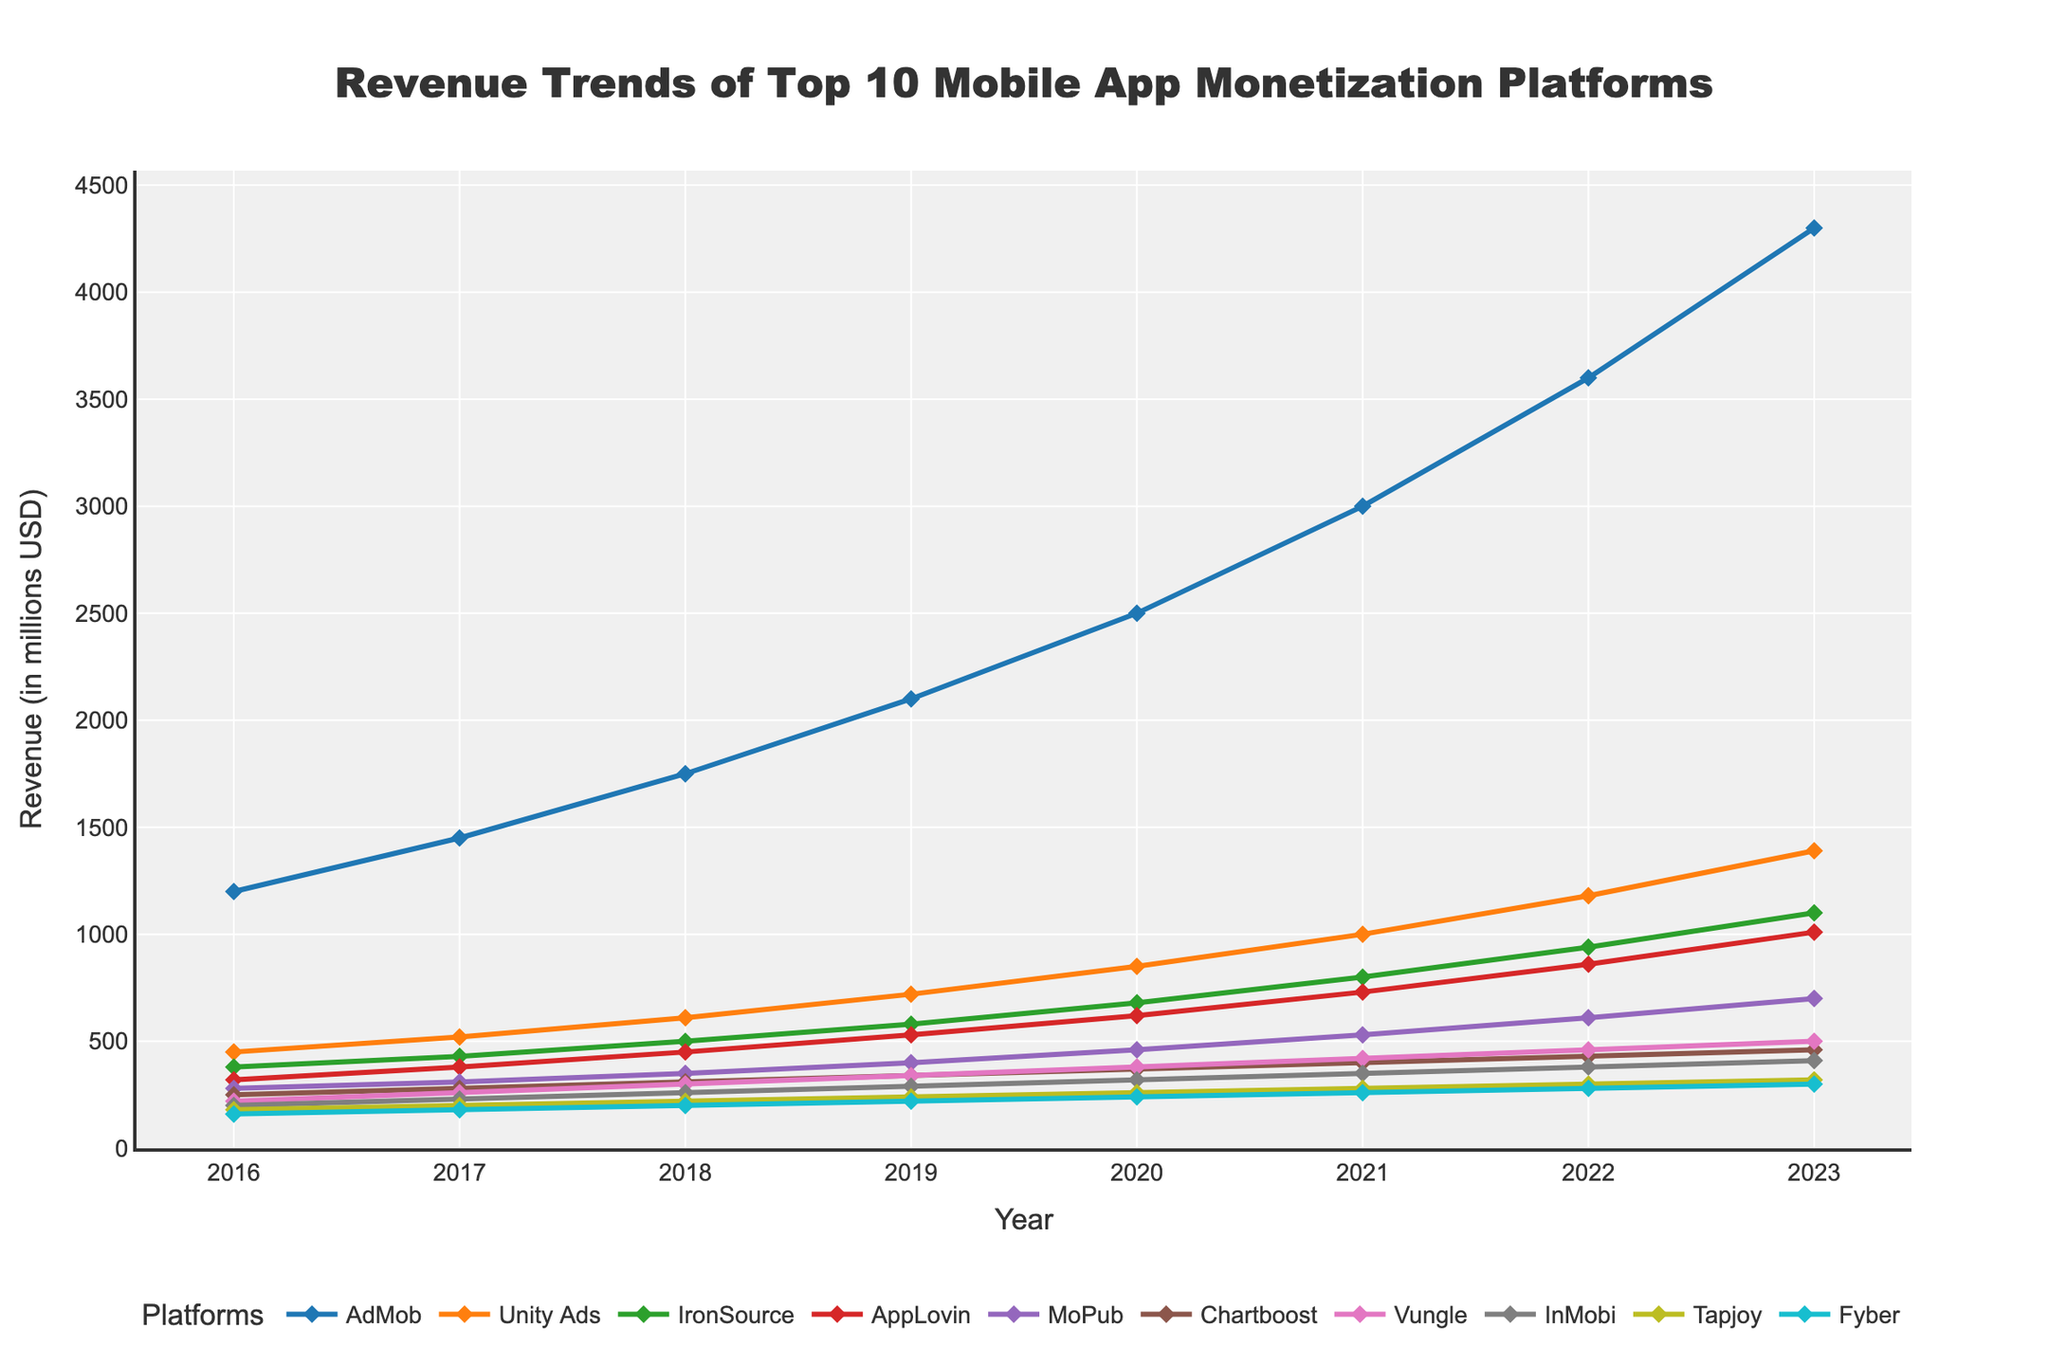What is the overall revenue trend of AdMob from 2016 to 2023? By examining the plot for the AdMob line (blue line), we can see that the revenue consistently rises each year from 1200 million USD in 2016 to 4300 million USD in 2023.
Answer: Increasing Which platform had the highest revenue in 2020? By checking the heights of the lines for the year 2020, it's clear that AdMob had the highest revenue at 2500 million USD.
Answer: AdMob How much did Unity Ads' revenue increase between 2018 and 2022? Looking at the line for Unity Ads (orange line), the revenue in 2018 was 610 million USD and in 2022 it was 1180 million USD. The increase is 1180 - 610 = 570 million USD.
Answer: 570 million USD Between Tapjoy and Fyber, which platform has shown a more consistent growth rate? Both Tapjoy (green line) and Fyber (grey line) show growth, but Tapjoy's annual increments (20-30 million USD) appear more consistent over the years compared to Fyber's smaller and steadier increments (15-20 million USD).
Answer: Tapjoy What was the average annual revenue of IronSource from 2016 to 2023? IronSource revenue in the years 2016 to 2023 are: 380, 430, 500, 580, 680, 800, 940, and 1100 million USD respectively. The sum of these values is 5410 million USD and the average over 8 years is 5410 / 8 = 676.25 million USD.
Answer: 676.25 million USD Which platform had a higher revenue in 2021, AppLovin or MoPub? In 2021, AppLovin's revenue was 730 million USD and MoPub's was 530 million USD. Comparing the two, AppLovin had the higher revenue.
Answer: AppLovin How did the revenue for Chartboost change from 2016 to 2023? From the chart, Chartboost's revenue (indigo line) starts at 250 million USD in 2016 and increases each year, reaching 460 million USD in 2023.
Answer: Increased What is the year-over-year revenue difference for Vungle from 2019 to 2020? For Vungle, the revenues were 340 million USD in 2019 and 380 million USD in 2020. The year-over-year difference is 380 - 340 = 40 million USD.
Answer: 40 million USD Which platform showed the highest revenue increase between 2021 and 2023? From the chart, AdMob showed an increase from 3000 million USD in 2021 to 4300 million USD in 2023, an increase of 1300 million USD, which is higher compared to other platforms.
Answer: AdMob 